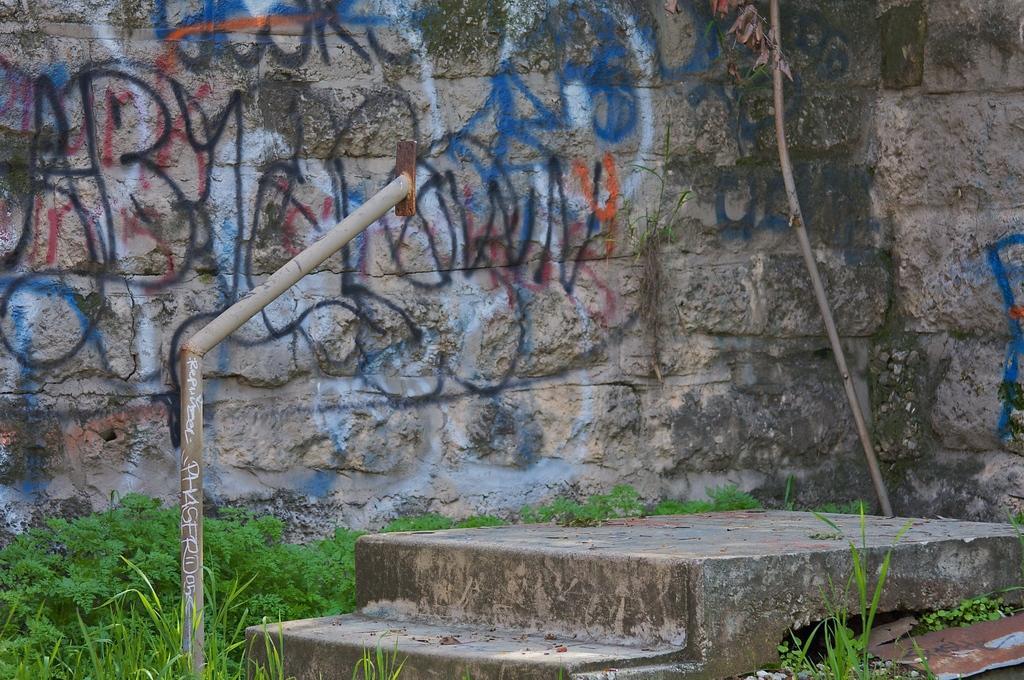Describe this image in one or two sentences. In this picture I can see there are stairs and a railing, there are plants, grass and in the backdrop I can see there is a wall and there is something written on it with spray cans. 